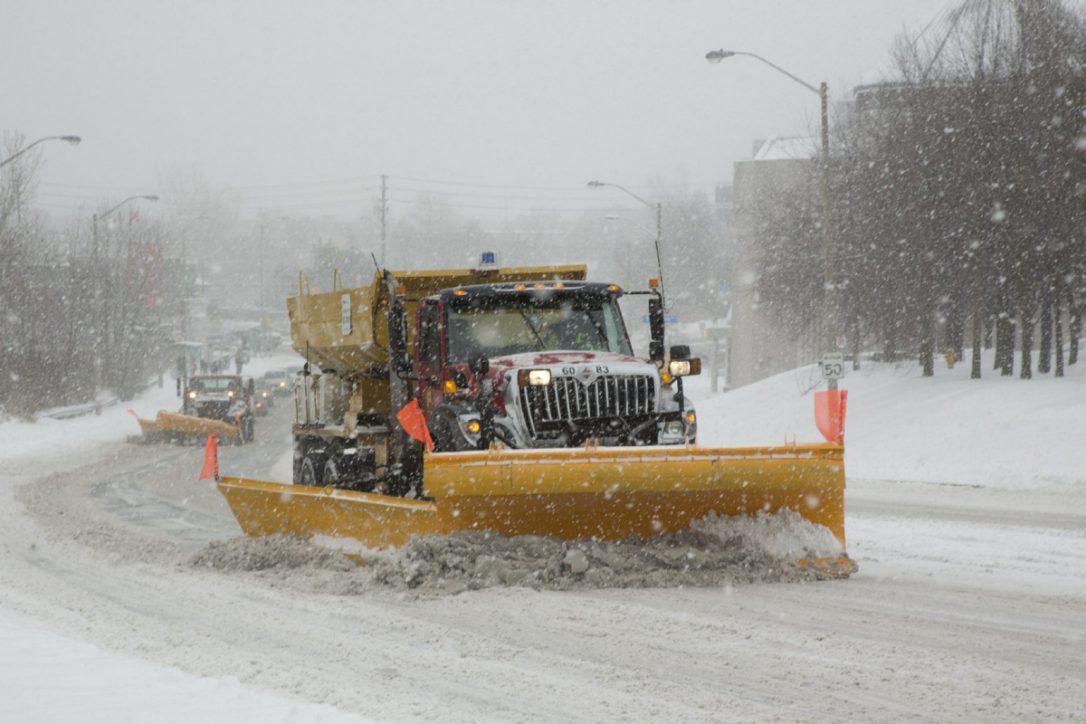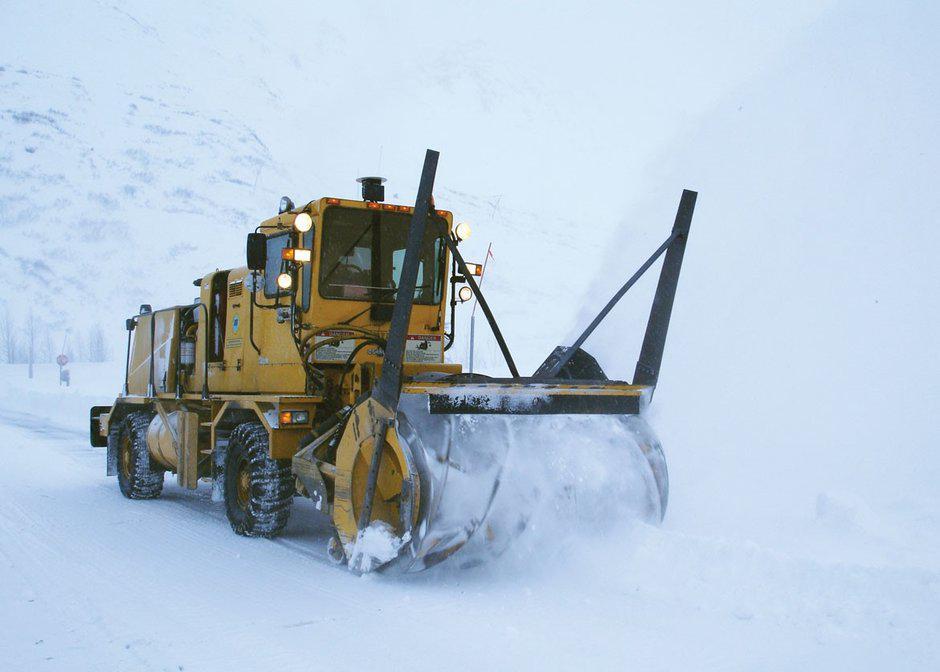The first image is the image on the left, the second image is the image on the right. Examine the images to the left and right. Is the description "there are two bulldozers facing the same direction" accurate? Answer yes or no. No. The first image is the image on the left, the second image is the image on the right. For the images shown, is this caption "The plow on the truck in the left image is yellow." true? Answer yes or no. Yes. 